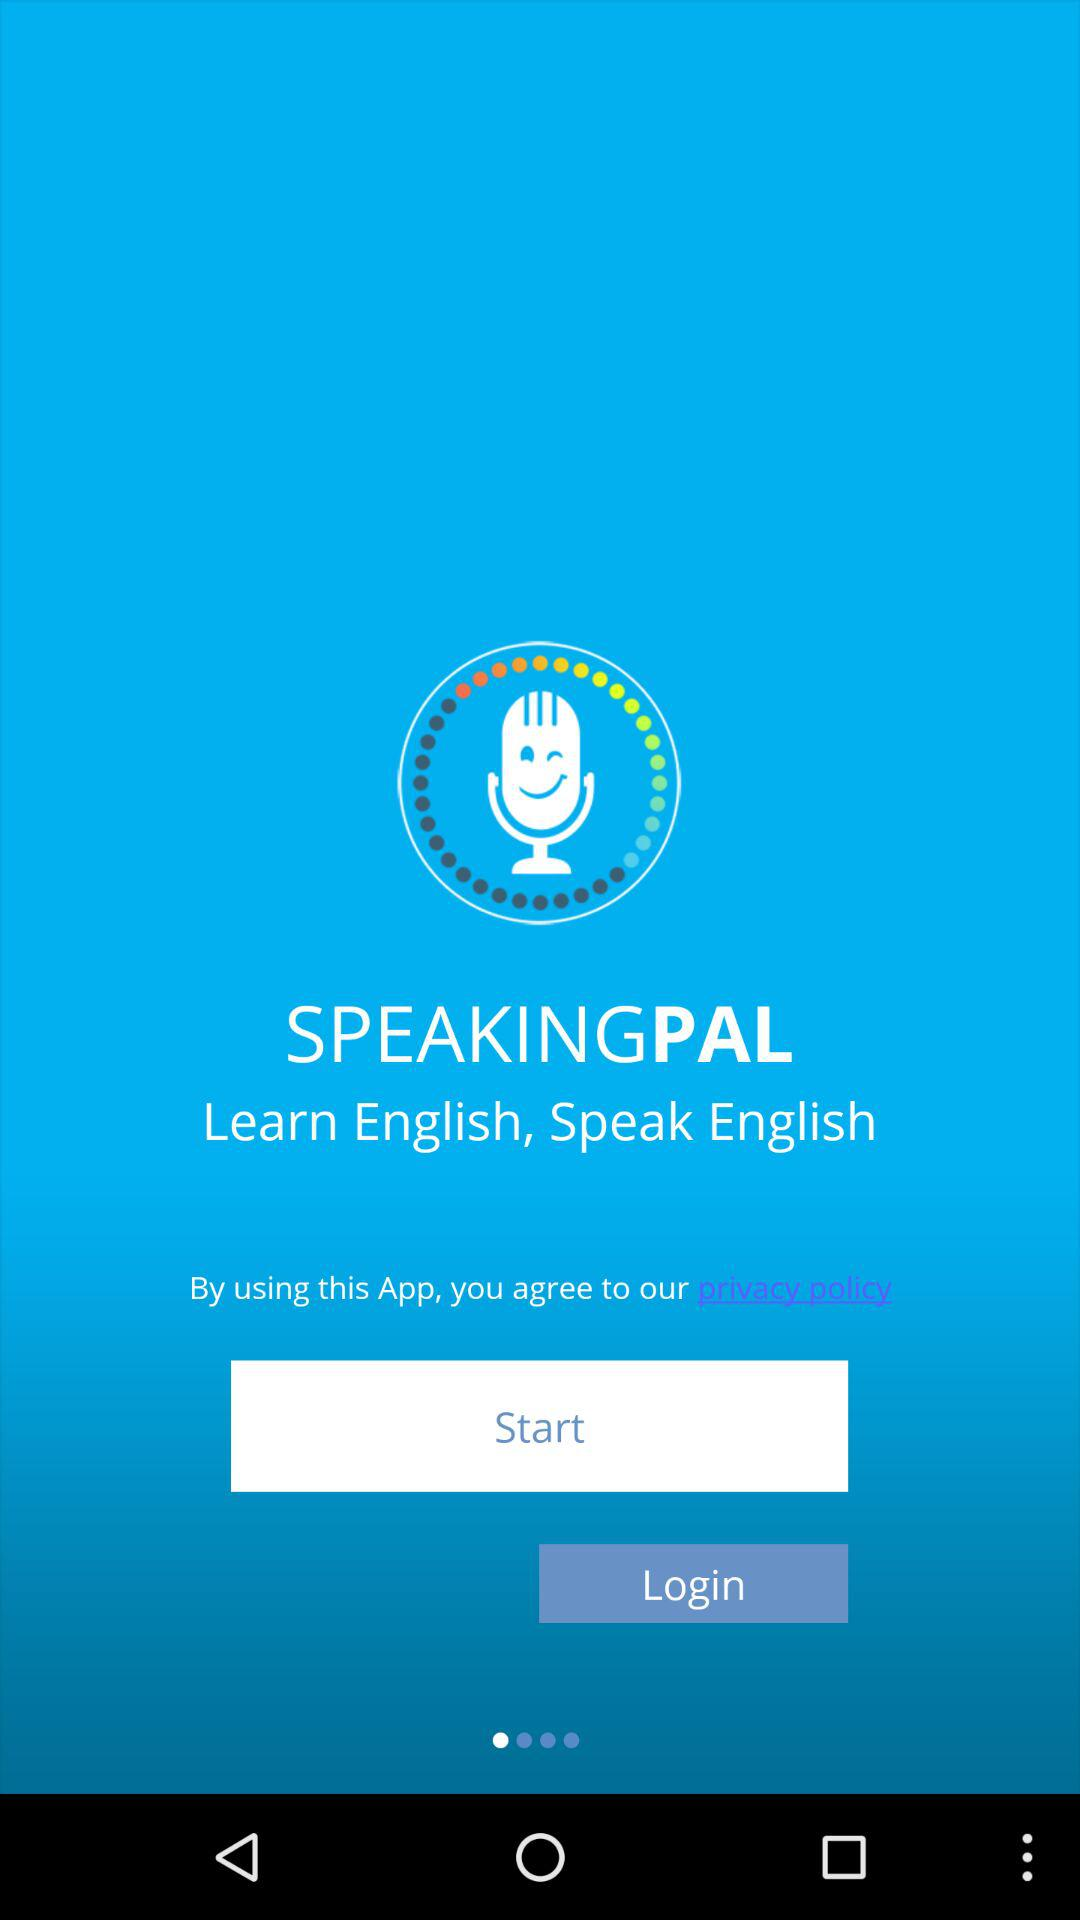What is the app name? The app name is "SPEAKINGPAL". 